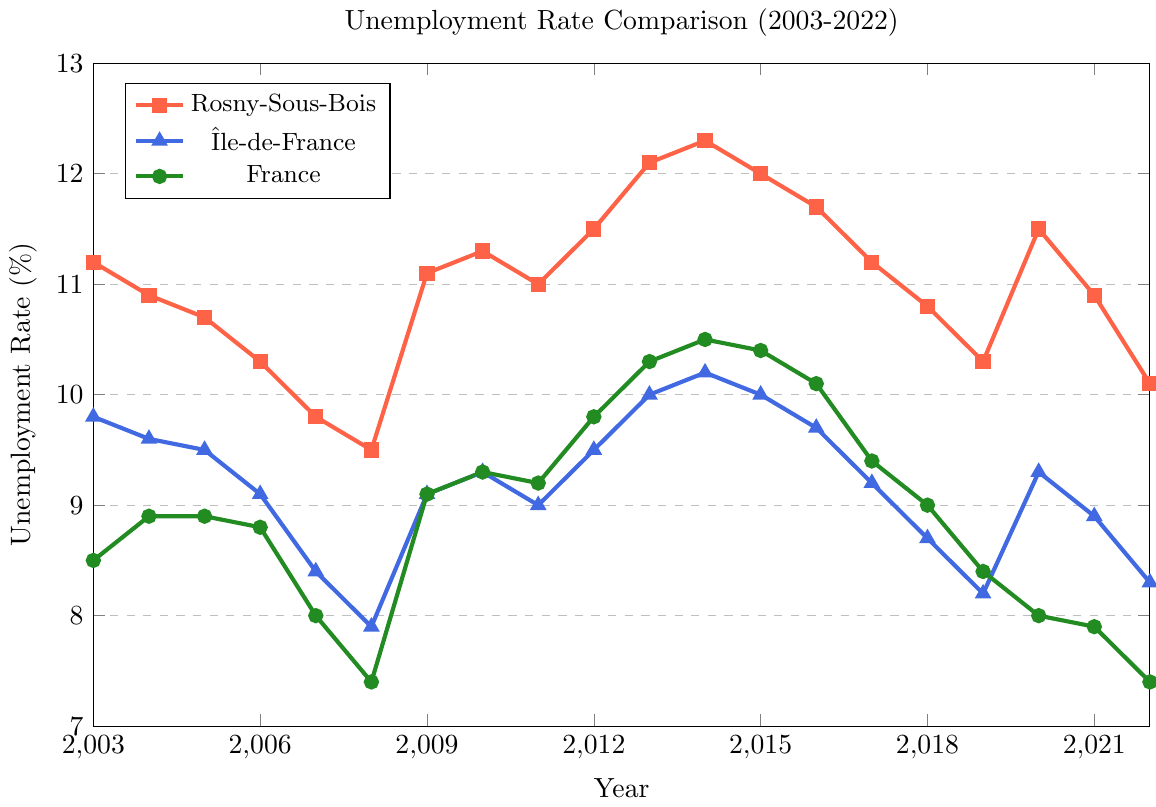What was the highest unemployment rate in Rosny-Sous-Bois over the last 20 years? To find the highest unemployment rate in Rosny-Sous-Bois, look for the tallest point on the red line. It peaks at 12.3% in 2014.
Answer: 12.3% In which year did Rosny-Sous-Bois have a lower unemployment rate compared to Île-de-France for the first time? Compare the red and blue lines from left to right. The first year the red line dips below the blue line is 2007.
Answer: 2007 How did the 2020 unemployment rate in Rosny-Sous-Bois compare with the national average? Locate the points for 2020 on the red and green lines. Rosny-Sous-Bois had an 11.5% rate, and France had an 8.0% rate. 11.5% (Rosny-Sous-Bois) is higher than 8.0% (France).
Answer: Higher What's the average unemployment rate in Rosny-Sous-Bois over the first 5 years (2003-2007)? Add the unemployment rates from 2003-2007: 11.2, 10.9, 10.7, 10.3, 9.8. The sum is 52.9. Dividing by 5 gives an average of 10.58%.
Answer: 10.58% Was the unemployment rate in Île-de-France ever higher than the national average? If so, in which year(s)? Compare the blue and green lines year by year. In 2013 and 2014, Île-de-France (10.0% and 10.2%) had higher rates than France (10.3% and 10.5%).
Answer: 2013, 2014 Which region showed the highest increase in unemployment rate between 2008 and 2009? The increase for each region is: Rosny-Sous-Bois: 11.1 - 9.5 = 1.6, Île-de-France: 9.1 - 7.9 = 1.2, France: 9.1 - 7.4 = 1.7. The highest increase is in France.
Answer: France What was the unemployment rate trend in Rosny-Sous-Bois from 2015 to 2019? Observe the red line from 2015 to 2019. It shows a downward trend from 12.0% in 2015 to 10.3% in 2019.
Answer: Downward 